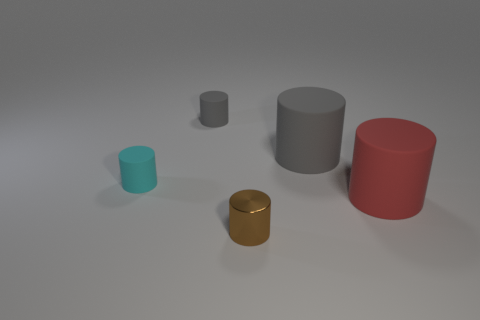Subtract all tiny cyan rubber cylinders. How many cylinders are left? 4 Subtract all gray cylinders. How many cylinders are left? 3 Subtract 3 cylinders. How many cylinders are left? 2 Subtract all yellow cylinders. Subtract all cyan cubes. How many cylinders are left? 5 Add 1 brown shiny objects. How many objects exist? 6 Add 2 large red matte things. How many large red matte things are left? 3 Add 4 small green metal things. How many small green metal things exist? 4 Subtract 0 blue blocks. How many objects are left? 5 Subtract all cyan rubber cylinders. Subtract all small rubber things. How many objects are left? 2 